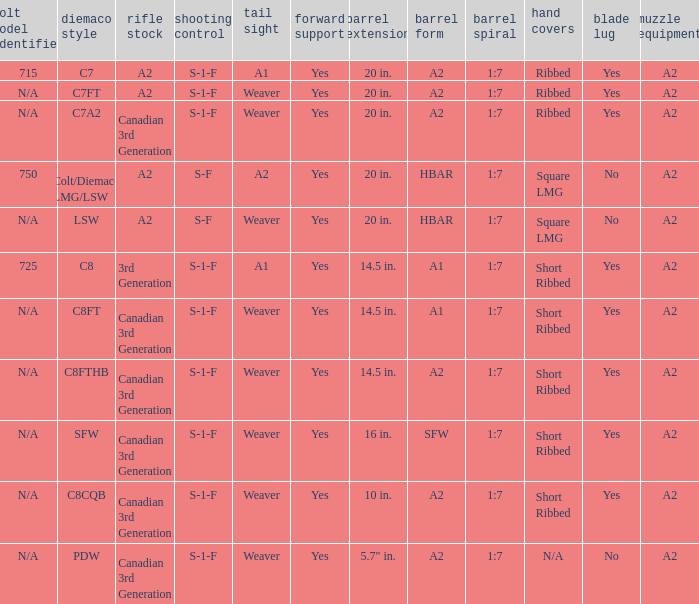Which Hand guards has a Barrel profile of a2 and a Rear sight of weaver? Ribbed, Ribbed, Short Ribbed, Short Ribbed, N/A. Could you help me parse every detail presented in this table? {'header': ['colt model identifier', 'diemaco style', 'rifle stock', 'shooting control', 'tail sight', 'forward support', 'barrel extension', 'barrel form', 'barrel spiral', 'hand covers', 'blade lug', 'muzzle equipment'], 'rows': [['715', 'C7', 'A2', 'S-1-F', 'A1', 'Yes', '20 in.', 'A2', '1:7', 'Ribbed', 'Yes', 'A2'], ['N/A', 'C7FT', 'A2', 'S-1-F', 'Weaver', 'Yes', '20 in.', 'A2', '1:7', 'Ribbed', 'Yes', 'A2'], ['N/A', 'C7A2', 'Canadian 3rd Generation', 'S-1-F', 'Weaver', 'Yes', '20 in.', 'A2', '1:7', 'Ribbed', 'Yes', 'A2'], ['750', 'Colt/Diemaco LMG/LSW', 'A2', 'S-F', 'A2', 'Yes', '20 in.', 'HBAR', '1:7', 'Square LMG', 'No', 'A2'], ['N/A', 'LSW', 'A2', 'S-F', 'Weaver', 'Yes', '20 in.', 'HBAR', '1:7', 'Square LMG', 'No', 'A2'], ['725', 'C8', '3rd Generation', 'S-1-F', 'A1', 'Yes', '14.5 in.', 'A1', '1:7', 'Short Ribbed', 'Yes', 'A2'], ['N/A', 'C8FT', 'Canadian 3rd Generation', 'S-1-F', 'Weaver', 'Yes', '14.5 in.', 'A1', '1:7', 'Short Ribbed', 'Yes', 'A2'], ['N/A', 'C8FTHB', 'Canadian 3rd Generation', 'S-1-F', 'Weaver', 'Yes', '14.5 in.', 'A2', '1:7', 'Short Ribbed', 'Yes', 'A2'], ['N/A', 'SFW', 'Canadian 3rd Generation', 'S-1-F', 'Weaver', 'Yes', '16 in.', 'SFW', '1:7', 'Short Ribbed', 'Yes', 'A2'], ['N/A', 'C8CQB', 'Canadian 3rd Generation', 'S-1-F', 'Weaver', 'Yes', '10 in.', 'A2', '1:7', 'Short Ribbed', 'Yes', 'A2'], ['N/A', 'PDW', 'Canadian 3rd Generation', 'S-1-F', 'Weaver', 'Yes', '5.7" in.', 'A2', '1:7', 'N/A', 'No', 'A2']]} 